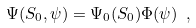Convert formula to latex. <formula><loc_0><loc_0><loc_500><loc_500>\Psi ( S _ { 0 } , \psi ) = \Psi _ { 0 } ( S _ { 0 } ) \Phi ( \psi ) \ ,</formula> 